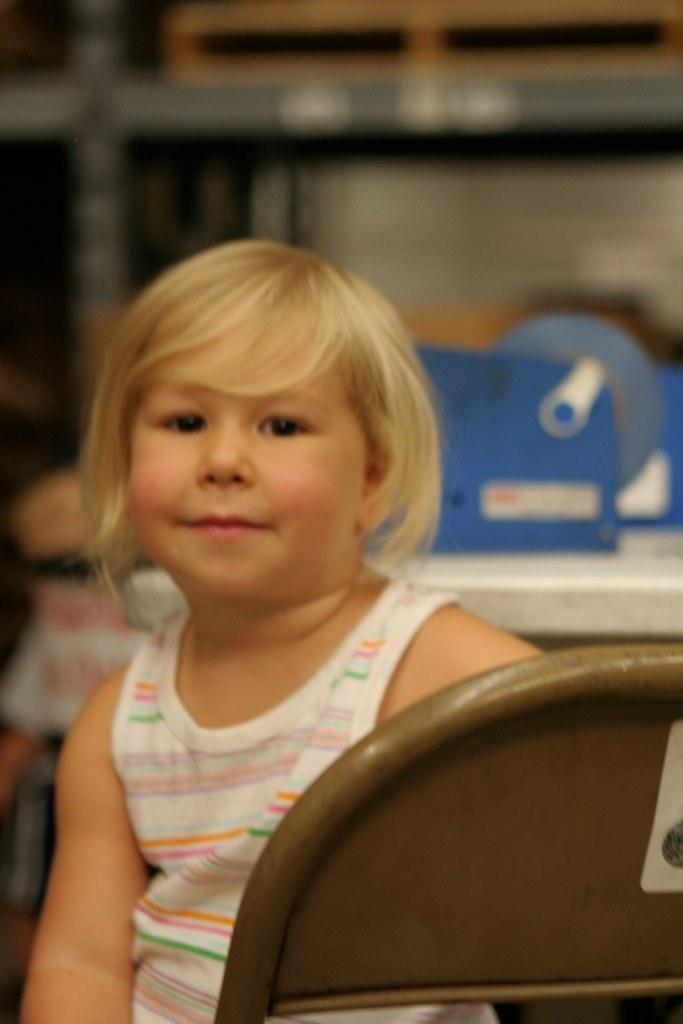What is the girl doing in the image? The girl is seated in the image. What is the girl sitting on? The girl is seated on a chair. What other furniture is visible in the image? There is a table visible in the image. What type of storage unit is present in the image? There is a metal shelf in the image. How many lizards can be seen sleeping on the girl's hair in the image? There are no lizards present in the image, and the girl's hair is not mentioned. 